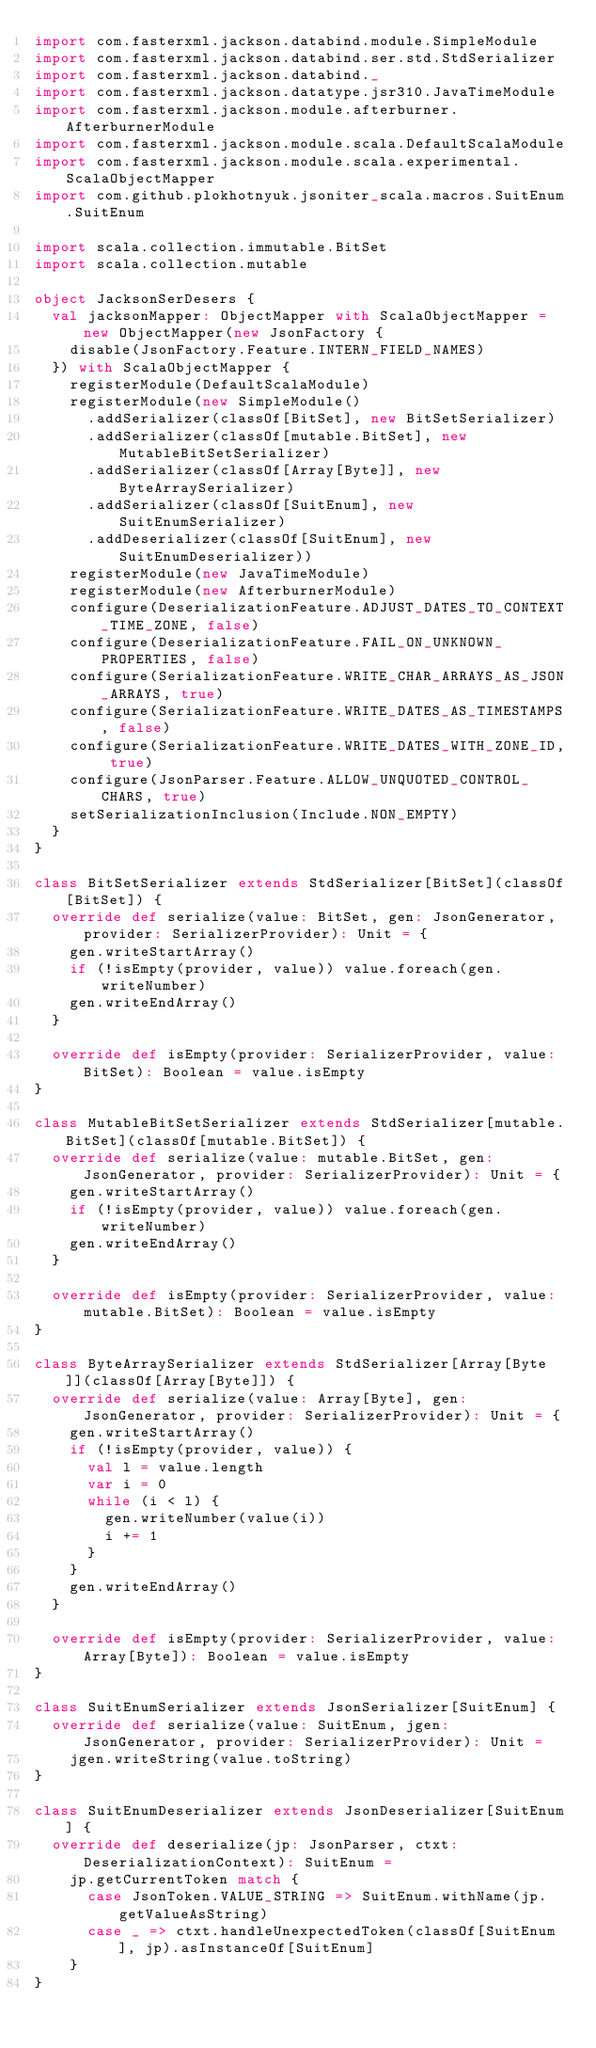Convert code to text. <code><loc_0><loc_0><loc_500><loc_500><_Scala_>import com.fasterxml.jackson.databind.module.SimpleModule
import com.fasterxml.jackson.databind.ser.std.StdSerializer
import com.fasterxml.jackson.databind._
import com.fasterxml.jackson.datatype.jsr310.JavaTimeModule
import com.fasterxml.jackson.module.afterburner.AfterburnerModule
import com.fasterxml.jackson.module.scala.DefaultScalaModule
import com.fasterxml.jackson.module.scala.experimental.ScalaObjectMapper
import com.github.plokhotnyuk.jsoniter_scala.macros.SuitEnum.SuitEnum

import scala.collection.immutable.BitSet
import scala.collection.mutable

object JacksonSerDesers {
  val jacksonMapper: ObjectMapper with ScalaObjectMapper = new ObjectMapper(new JsonFactory {
    disable(JsonFactory.Feature.INTERN_FIELD_NAMES)
  }) with ScalaObjectMapper {
    registerModule(DefaultScalaModule)
    registerModule(new SimpleModule()
      .addSerializer(classOf[BitSet], new BitSetSerializer)
      .addSerializer(classOf[mutable.BitSet], new MutableBitSetSerializer)
      .addSerializer(classOf[Array[Byte]], new ByteArraySerializer)
      .addSerializer(classOf[SuitEnum], new SuitEnumSerializer)
      .addDeserializer(classOf[SuitEnum], new SuitEnumDeserializer))
    registerModule(new JavaTimeModule)
    registerModule(new AfterburnerModule)
    configure(DeserializationFeature.ADJUST_DATES_TO_CONTEXT_TIME_ZONE, false)
    configure(DeserializationFeature.FAIL_ON_UNKNOWN_PROPERTIES, false)
    configure(SerializationFeature.WRITE_CHAR_ARRAYS_AS_JSON_ARRAYS, true)
    configure(SerializationFeature.WRITE_DATES_AS_TIMESTAMPS, false)
    configure(SerializationFeature.WRITE_DATES_WITH_ZONE_ID, true)
    configure(JsonParser.Feature.ALLOW_UNQUOTED_CONTROL_CHARS, true)
    setSerializationInclusion(Include.NON_EMPTY)
  }
}

class BitSetSerializer extends StdSerializer[BitSet](classOf[BitSet]) {
  override def serialize(value: BitSet, gen: JsonGenerator, provider: SerializerProvider): Unit = {
    gen.writeStartArray()
    if (!isEmpty(provider, value)) value.foreach(gen.writeNumber)
    gen.writeEndArray()
  }

  override def isEmpty(provider: SerializerProvider, value: BitSet): Boolean = value.isEmpty
}

class MutableBitSetSerializer extends StdSerializer[mutable.BitSet](classOf[mutable.BitSet]) {
  override def serialize(value: mutable.BitSet, gen: JsonGenerator, provider: SerializerProvider): Unit = {
    gen.writeStartArray()
    if (!isEmpty(provider, value)) value.foreach(gen.writeNumber)
    gen.writeEndArray()
  }

  override def isEmpty(provider: SerializerProvider, value: mutable.BitSet): Boolean = value.isEmpty
}

class ByteArraySerializer extends StdSerializer[Array[Byte]](classOf[Array[Byte]]) {
  override def serialize(value: Array[Byte], gen: JsonGenerator, provider: SerializerProvider): Unit = {
    gen.writeStartArray()
    if (!isEmpty(provider, value)) {
      val l = value.length
      var i = 0
      while (i < l) {
        gen.writeNumber(value(i))
        i += 1
      }
    }
    gen.writeEndArray()
  }

  override def isEmpty(provider: SerializerProvider, value: Array[Byte]): Boolean = value.isEmpty
}

class SuitEnumSerializer extends JsonSerializer[SuitEnum] {
  override def serialize(value: SuitEnum, jgen: JsonGenerator, provider: SerializerProvider): Unit =
    jgen.writeString(value.toString)
}

class SuitEnumDeserializer extends JsonDeserializer[SuitEnum] {
  override def deserialize(jp: JsonParser, ctxt: DeserializationContext): SuitEnum =
    jp.getCurrentToken match {
      case JsonToken.VALUE_STRING => SuitEnum.withName(jp.getValueAsString)
      case _ => ctxt.handleUnexpectedToken(classOf[SuitEnum], jp).asInstanceOf[SuitEnum]
    }
}</code> 